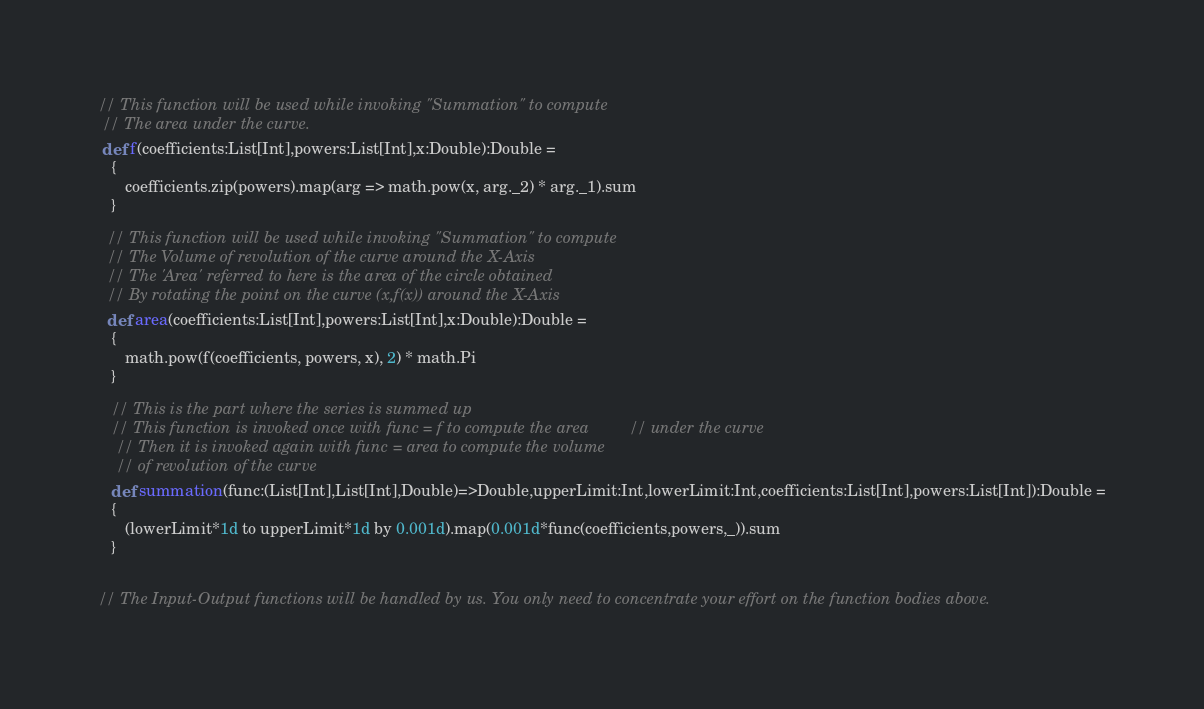<code> <loc_0><loc_0><loc_500><loc_500><_Scala_>// This function will be used while invoking "Summation" to compute
 // The area under the curve.
 def f(coefficients:List[Int],powers:List[Int],x:Double):Double =
   {
      coefficients.zip(powers).map(arg => math.pow(x, arg._2) * arg._1).sum
   }

  // This function will be used while invoking "Summation" to compute
  // The Volume of revolution of the curve around the X-Axis
  // The 'Area' referred to here is the area of the circle obtained
  // By rotating the point on the curve (x,f(x)) around the X-Axis
  def area(coefficients:List[Int],powers:List[Int],x:Double):Double =
   {
      math.pow(f(coefficients, powers, x), 2) * math.Pi
   }

   // This is the part where the series is summed up
   // This function is invoked once with func = f to compute the area         // under the curve
    // Then it is invoked again with func = area to compute the volume
    // of revolution of the curve
   def summation(func:(List[Int],List[Int],Double)=>Double,upperLimit:Int,lowerLimit:Int,coefficients:List[Int],powers:List[Int]):Double =
   {
      (lowerLimit*1d to upperLimit*1d by 0.001d).map(0.001d*func(coefficients,powers,_)).sum
   }


// The Input-Output functions will be handled by us. You only need to concentrate your effort on the function bodies above.
</code> 